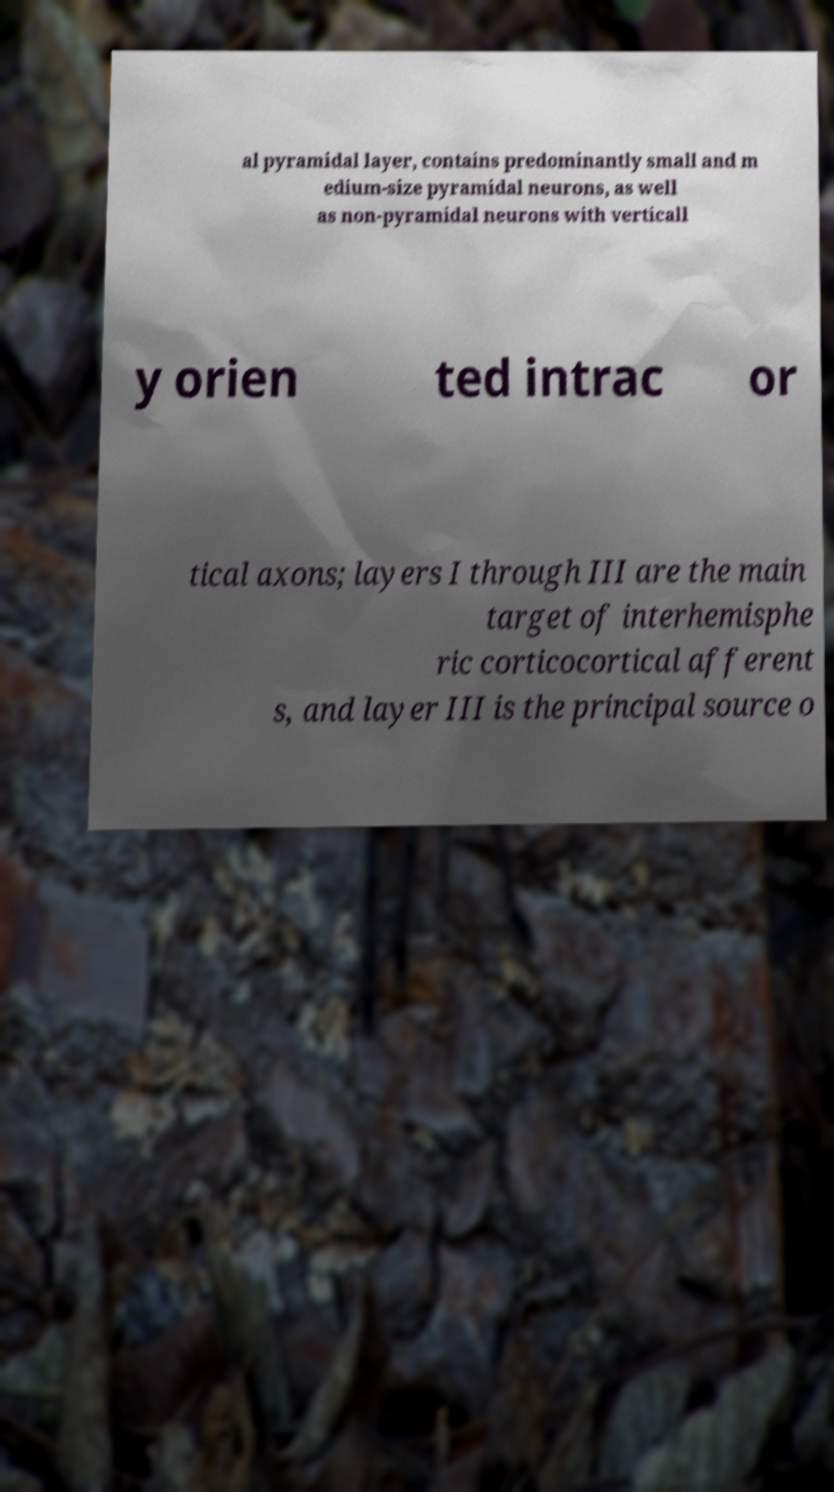There's text embedded in this image that I need extracted. Can you transcribe it verbatim? al pyramidal layer, contains predominantly small and m edium-size pyramidal neurons, as well as non-pyramidal neurons with verticall y orien ted intrac or tical axons; layers I through III are the main target of interhemisphe ric corticocortical afferent s, and layer III is the principal source o 